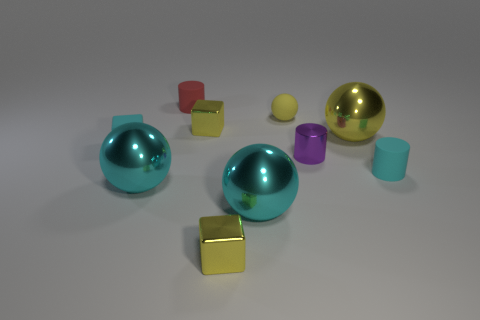How many small cyan blocks have the same material as the small ball?
Your response must be concise. 1. How many large cyan objects are there?
Your answer should be compact. 2. Is the color of the small block that is behind the cyan rubber block the same as the tiny cylinder behind the small purple metallic thing?
Keep it short and to the point. No. There is a small yellow rubber sphere; how many cylinders are in front of it?
Make the answer very short. 2. There is a tiny thing that is the same color as the rubber cube; what material is it?
Provide a succinct answer. Rubber. Is there another large yellow shiny object of the same shape as the large yellow metallic thing?
Your answer should be compact. No. Does the cylinder behind the small metallic cylinder have the same material as the yellow ball left of the small purple object?
Provide a short and direct response. Yes. There is a yellow thing that is in front of the metal thing that is on the left side of the metallic block that is behind the big yellow metallic ball; what size is it?
Give a very brief answer. Small. There is a purple object that is the same size as the cyan matte cube; what material is it?
Make the answer very short. Metal. Is there a cyan rubber block of the same size as the red matte cylinder?
Provide a succinct answer. Yes. 